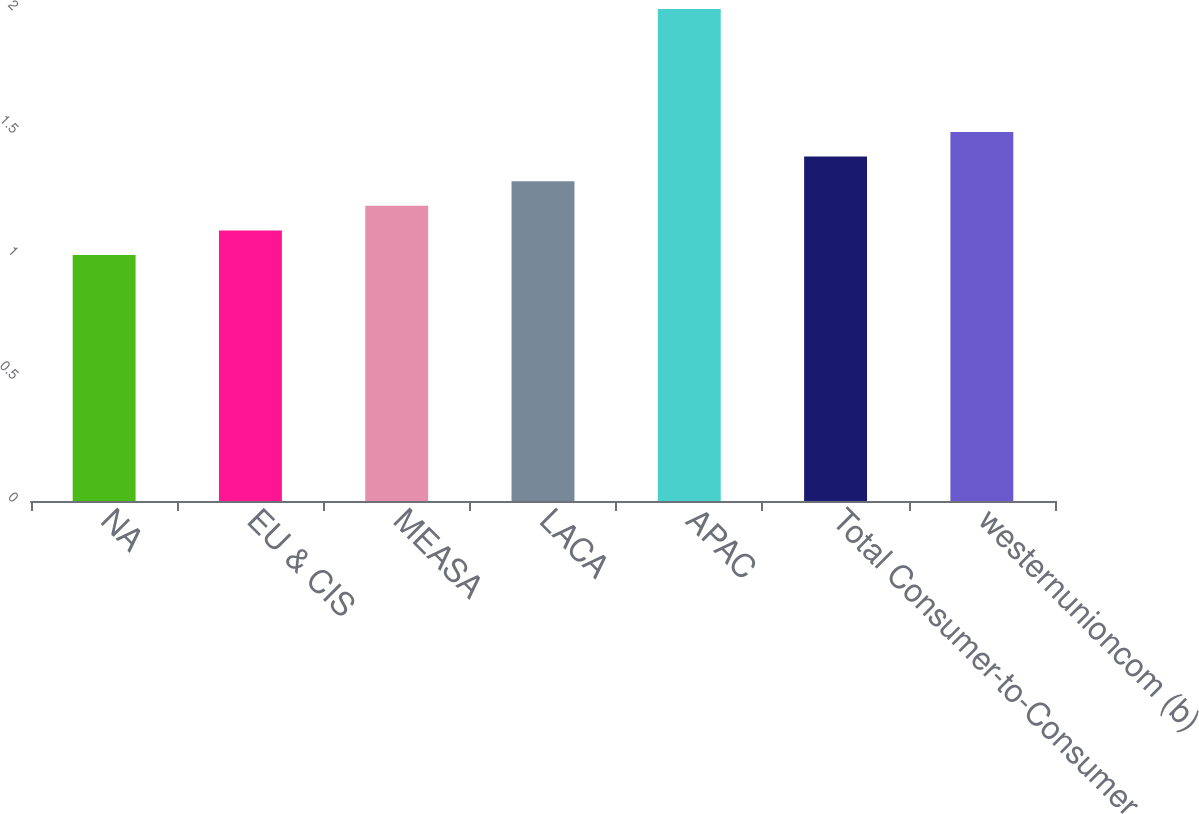Convert chart. <chart><loc_0><loc_0><loc_500><loc_500><bar_chart><fcel>NA<fcel>EU & CIS<fcel>MEASA<fcel>LACA<fcel>APAC<fcel>Total Consumer-to-Consumer<fcel>westernunioncom (b)<nl><fcel>1<fcel>1.1<fcel>1.2<fcel>1.3<fcel>2<fcel>1.4<fcel>1.5<nl></chart> 